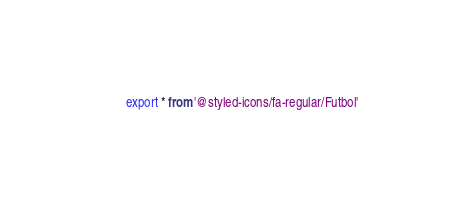<code> <loc_0><loc_0><loc_500><loc_500><_TypeScript_>export * from '@styled-icons/fa-regular/Futbol'</code> 